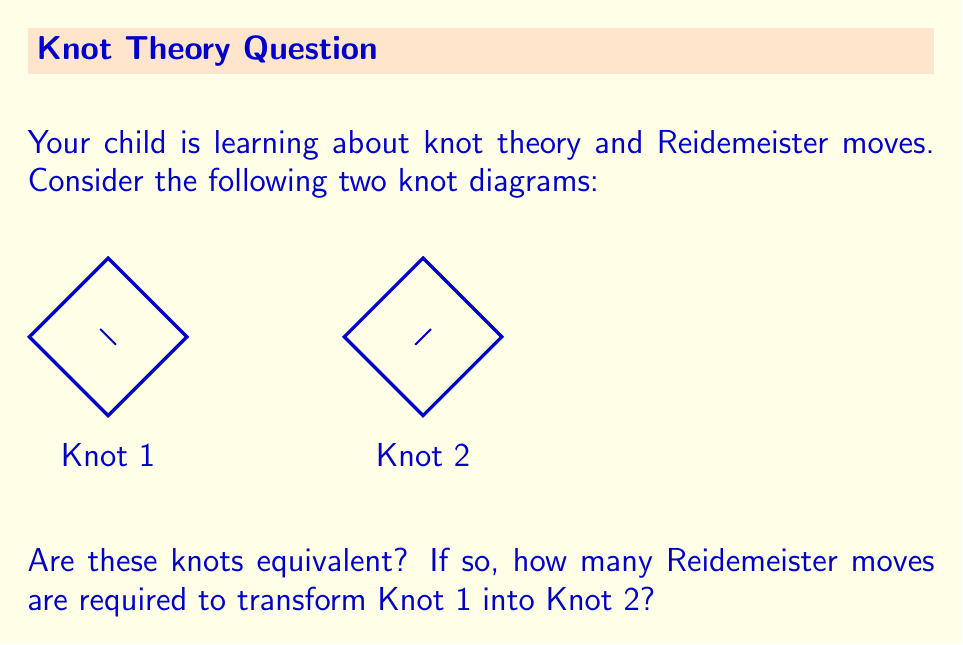Show me your answer to this math problem. To determine if the knots are equivalent and how many Reidemeister moves are required, let's analyze the diagrams:

1. Both knots are trefoil knots, which suggests they might be equivalent.

2. The main difference between the two diagrams is the crossing orientation at the bottom of each knot.

3. To transform Knot 1 into Knot 2, we need to change the crossing at the bottom:
   - This can be achieved using a Reidemeister move of type III.

4. The Reidemeister move of type III allows us to slide one strand over or under a crossing point.

5. In this case, we can apply the type III move as follows:
   a. Imagine slightly stretching the bottom loop of Knot 1.
   b. Slide the right strand of this loop under the crossing point.
   c. This action switches the over and under crossings at the bottom.

6. After applying this single Reidemeister move of type III, Knot 1 will be identical to Knot 2.

Therefore, the knots are equivalent, and only one Reidemeister move is required to transform Knot 1 into Knot 2.
Answer: Yes, 1 move 